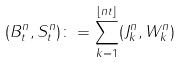Convert formula to latex. <formula><loc_0><loc_0><loc_500><loc_500>( B ^ { n } _ { t } , S ^ { n } _ { t } ) \colon = \sum _ { k = 1 } ^ { \lfloor n t \rfloor } ( J ^ { n } _ { k } , W ^ { n } _ { k } )</formula> 